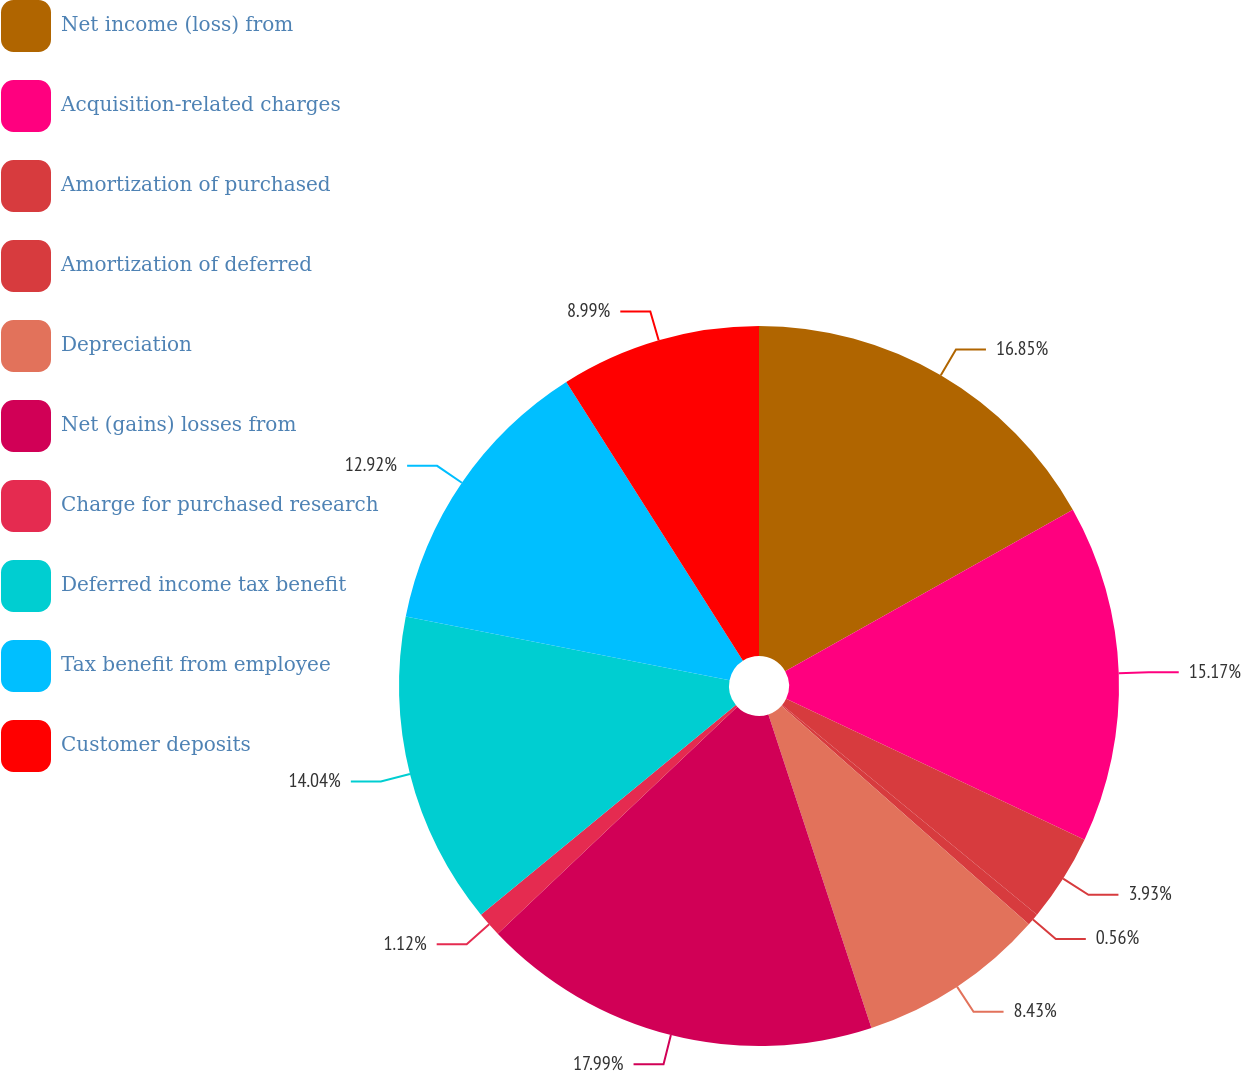<chart> <loc_0><loc_0><loc_500><loc_500><pie_chart><fcel>Net income (loss) from<fcel>Acquisition-related charges<fcel>Amortization of purchased<fcel>Amortization of deferred<fcel>Depreciation<fcel>Net (gains) losses from<fcel>Charge for purchased research<fcel>Deferred income tax benefit<fcel>Tax benefit from employee<fcel>Customer deposits<nl><fcel>16.85%<fcel>15.17%<fcel>3.93%<fcel>0.56%<fcel>8.43%<fcel>17.98%<fcel>1.12%<fcel>14.04%<fcel>12.92%<fcel>8.99%<nl></chart> 